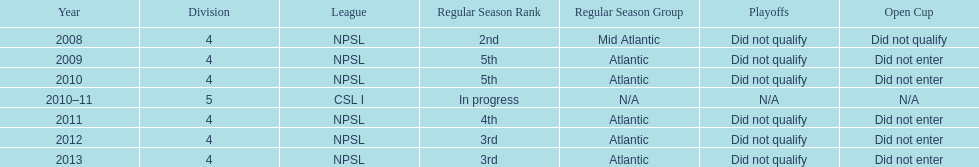In what year only did they compete in division 5 2010-11. 